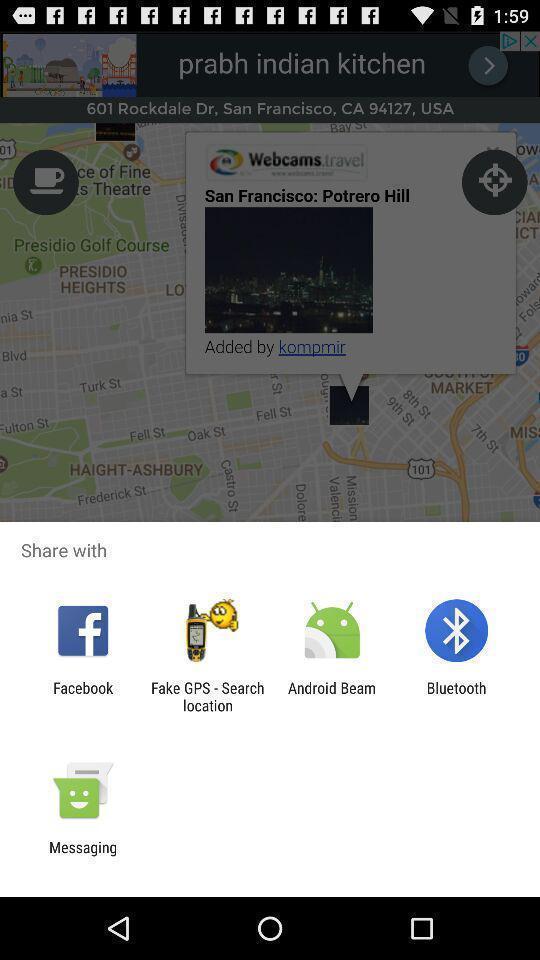Provide a textual representation of this image. Push up page showing app preference to share. 